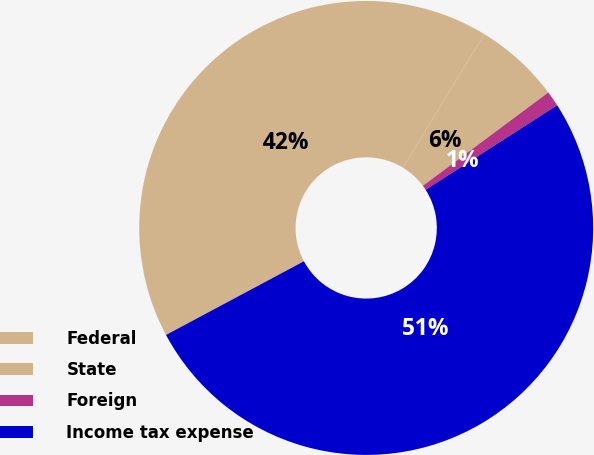Convert chart. <chart><loc_0><loc_0><loc_500><loc_500><pie_chart><fcel>Federal<fcel>State<fcel>Foreign<fcel>Income tax expense<nl><fcel>41.52%<fcel>6.11%<fcel>1.09%<fcel>51.28%<nl></chart> 